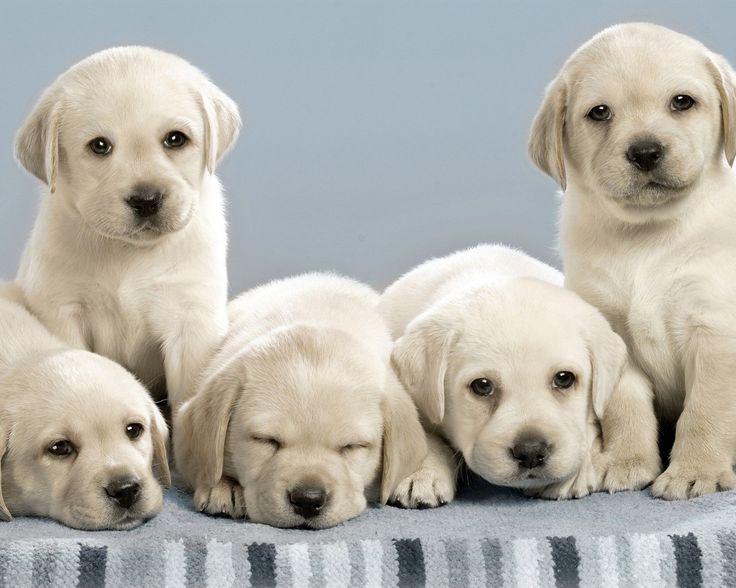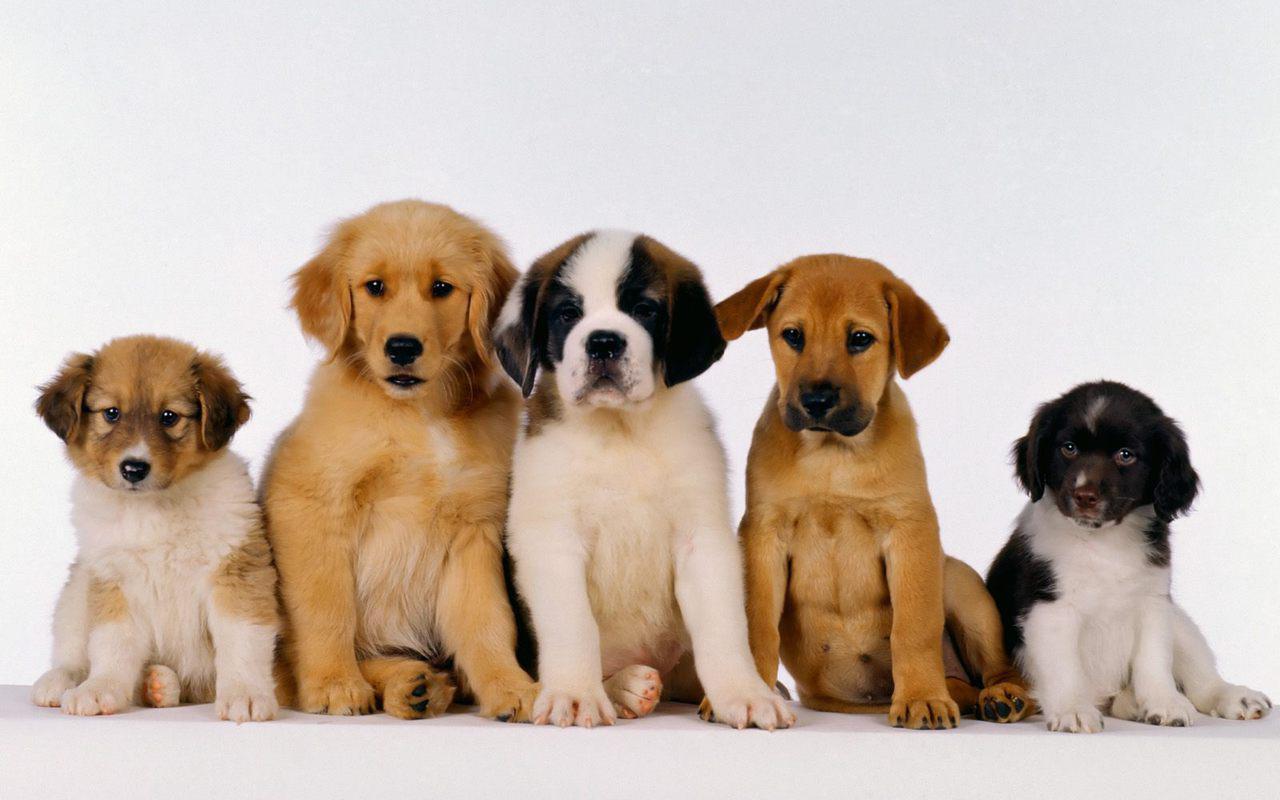The first image is the image on the left, the second image is the image on the right. Examine the images to the left and right. Is the description "One of the images in the pair contains at least ten dogs." accurate? Answer yes or no. No. 